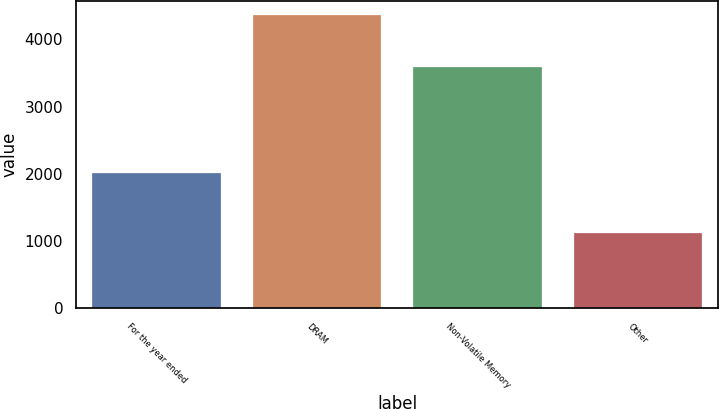<chart> <loc_0><loc_0><loc_500><loc_500><bar_chart><fcel>For the year ended<fcel>DRAM<fcel>Non-Volatile Memory<fcel>Other<nl><fcel>2013<fcel>4361<fcel>3589<fcel>1123<nl></chart> 